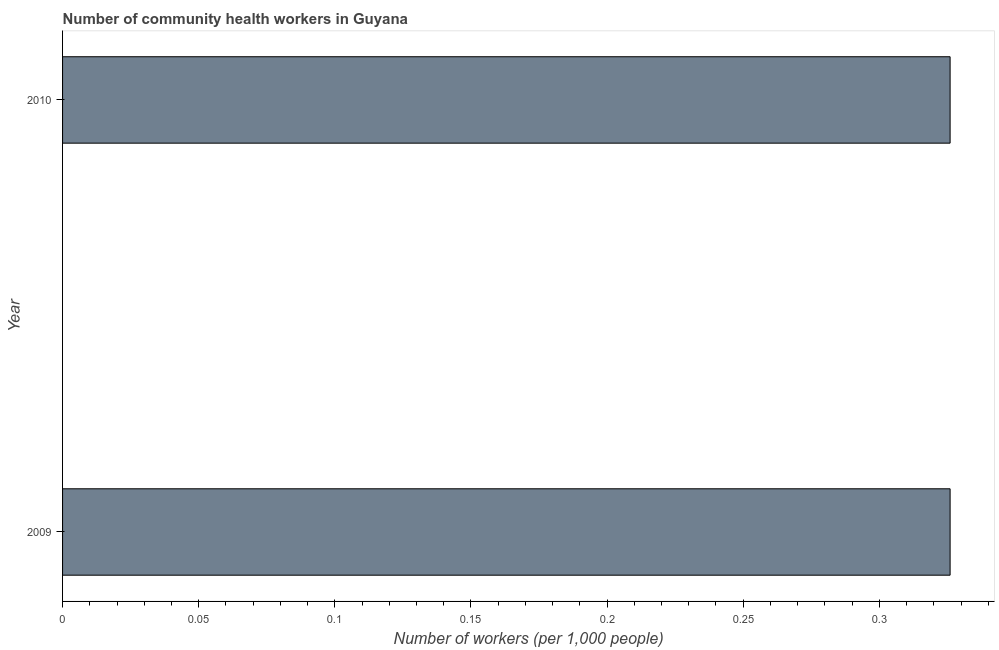Does the graph contain grids?
Your response must be concise. No. What is the title of the graph?
Your response must be concise. Number of community health workers in Guyana. What is the label or title of the X-axis?
Ensure brevity in your answer.  Number of workers (per 1,0 people). What is the number of community health workers in 2010?
Your answer should be very brief. 0.33. Across all years, what is the maximum number of community health workers?
Keep it short and to the point. 0.33. Across all years, what is the minimum number of community health workers?
Your answer should be compact. 0.33. In which year was the number of community health workers maximum?
Your answer should be very brief. 2009. In which year was the number of community health workers minimum?
Make the answer very short. 2009. What is the sum of the number of community health workers?
Give a very brief answer. 0.65. What is the average number of community health workers per year?
Offer a terse response. 0.33. What is the median number of community health workers?
Give a very brief answer. 0.33. In how many years, is the number of community health workers greater than 0.27 ?
Provide a succinct answer. 2. Do a majority of the years between 2009 and 2010 (inclusive) have number of community health workers greater than 0.13 ?
Your response must be concise. Yes. Is the number of community health workers in 2009 less than that in 2010?
Make the answer very short. No. How many bars are there?
Keep it short and to the point. 2. What is the difference between two consecutive major ticks on the X-axis?
Make the answer very short. 0.05. Are the values on the major ticks of X-axis written in scientific E-notation?
Give a very brief answer. No. What is the Number of workers (per 1,000 people) in 2009?
Make the answer very short. 0.33. What is the Number of workers (per 1,000 people) of 2010?
Your answer should be very brief. 0.33. What is the difference between the Number of workers (per 1,000 people) in 2009 and 2010?
Your response must be concise. 0. What is the ratio of the Number of workers (per 1,000 people) in 2009 to that in 2010?
Keep it short and to the point. 1. 